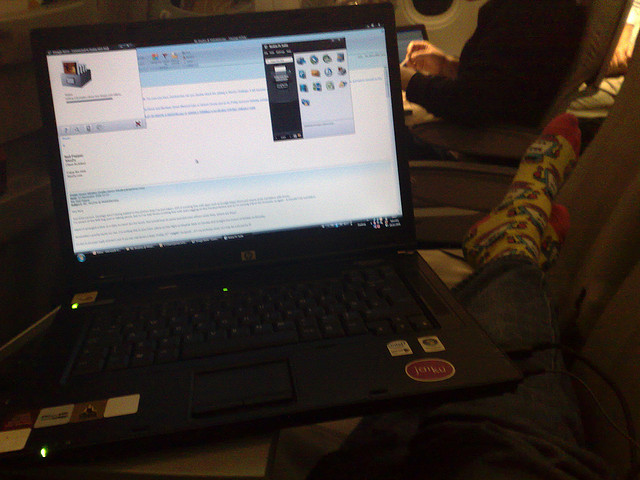What type of electronic device is shown in the image, and what can you infer about its user? The image shows a laptop computer, identifiable by the visible keyboard and screen displaying an operating system interface. From the casual setting and the person's relaxed attire, including colorful socks, one might infer that the user is in a personal, non-formal environment, possibly at home or during travel, utilizing the laptop for work or leisure. 